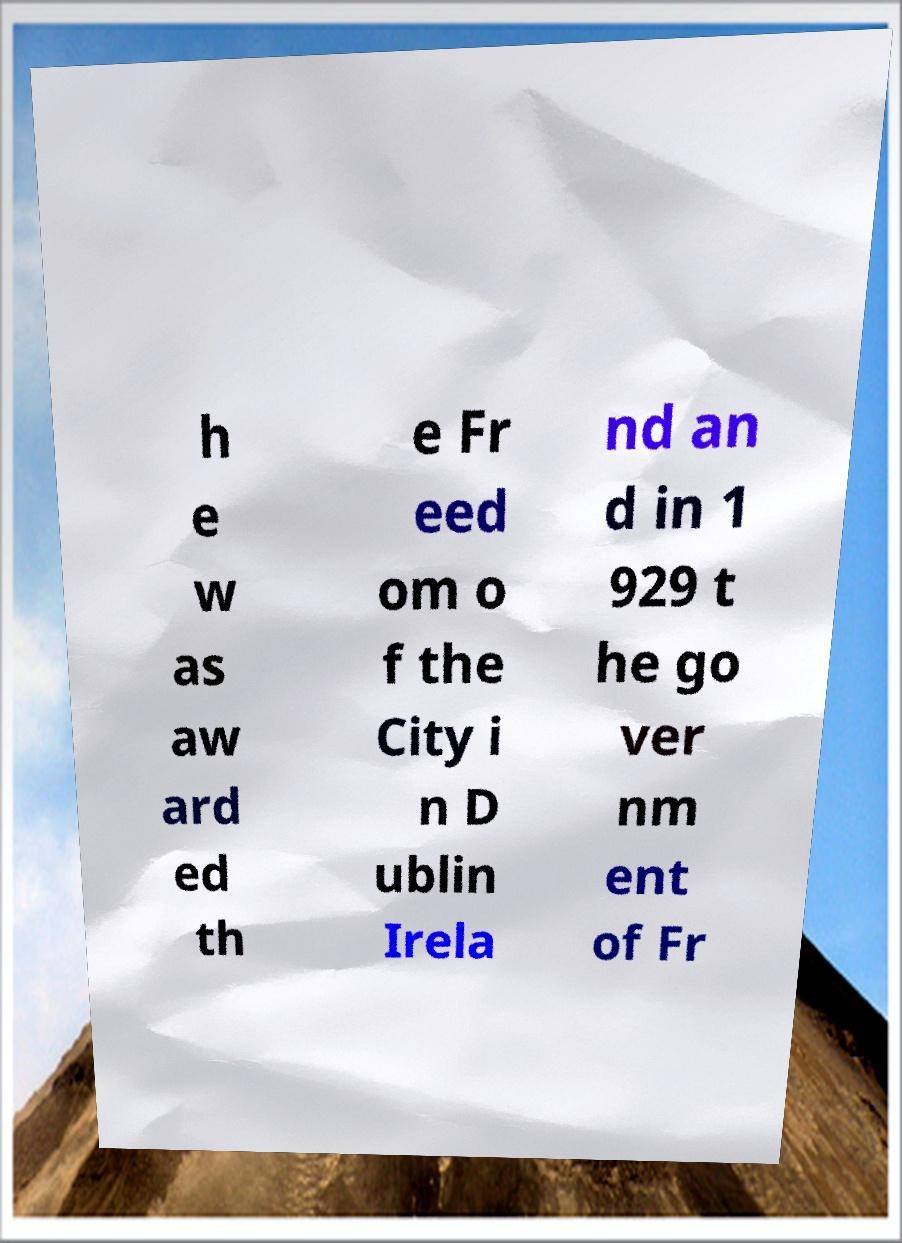For documentation purposes, I need the text within this image transcribed. Could you provide that? h e w as aw ard ed th e Fr eed om o f the City i n D ublin Irela nd an d in 1 929 t he go ver nm ent of Fr 